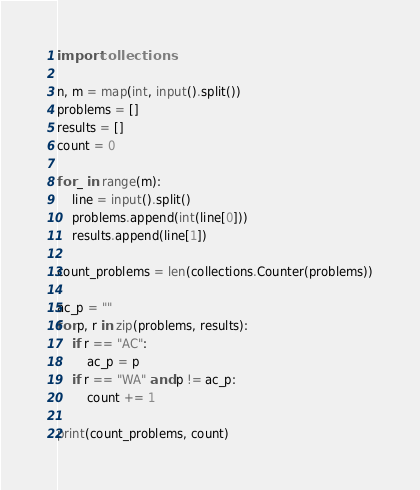Convert code to text. <code><loc_0><loc_0><loc_500><loc_500><_Python_>import collections

n, m = map(int, input().split())
problems = []
results = []
count = 0

for _ in range(m):
    line = input().split()
    problems.append(int(line[0]))
    results.append(line[1])

count_problems = len(collections.Counter(problems))

ac_p = ""
for p, r in zip(problems, results):
    if r == "AC":
        ac_p = p
    if r == "WA" and p != ac_p:
        count += 1
    
print(count_problems, count)
</code> 